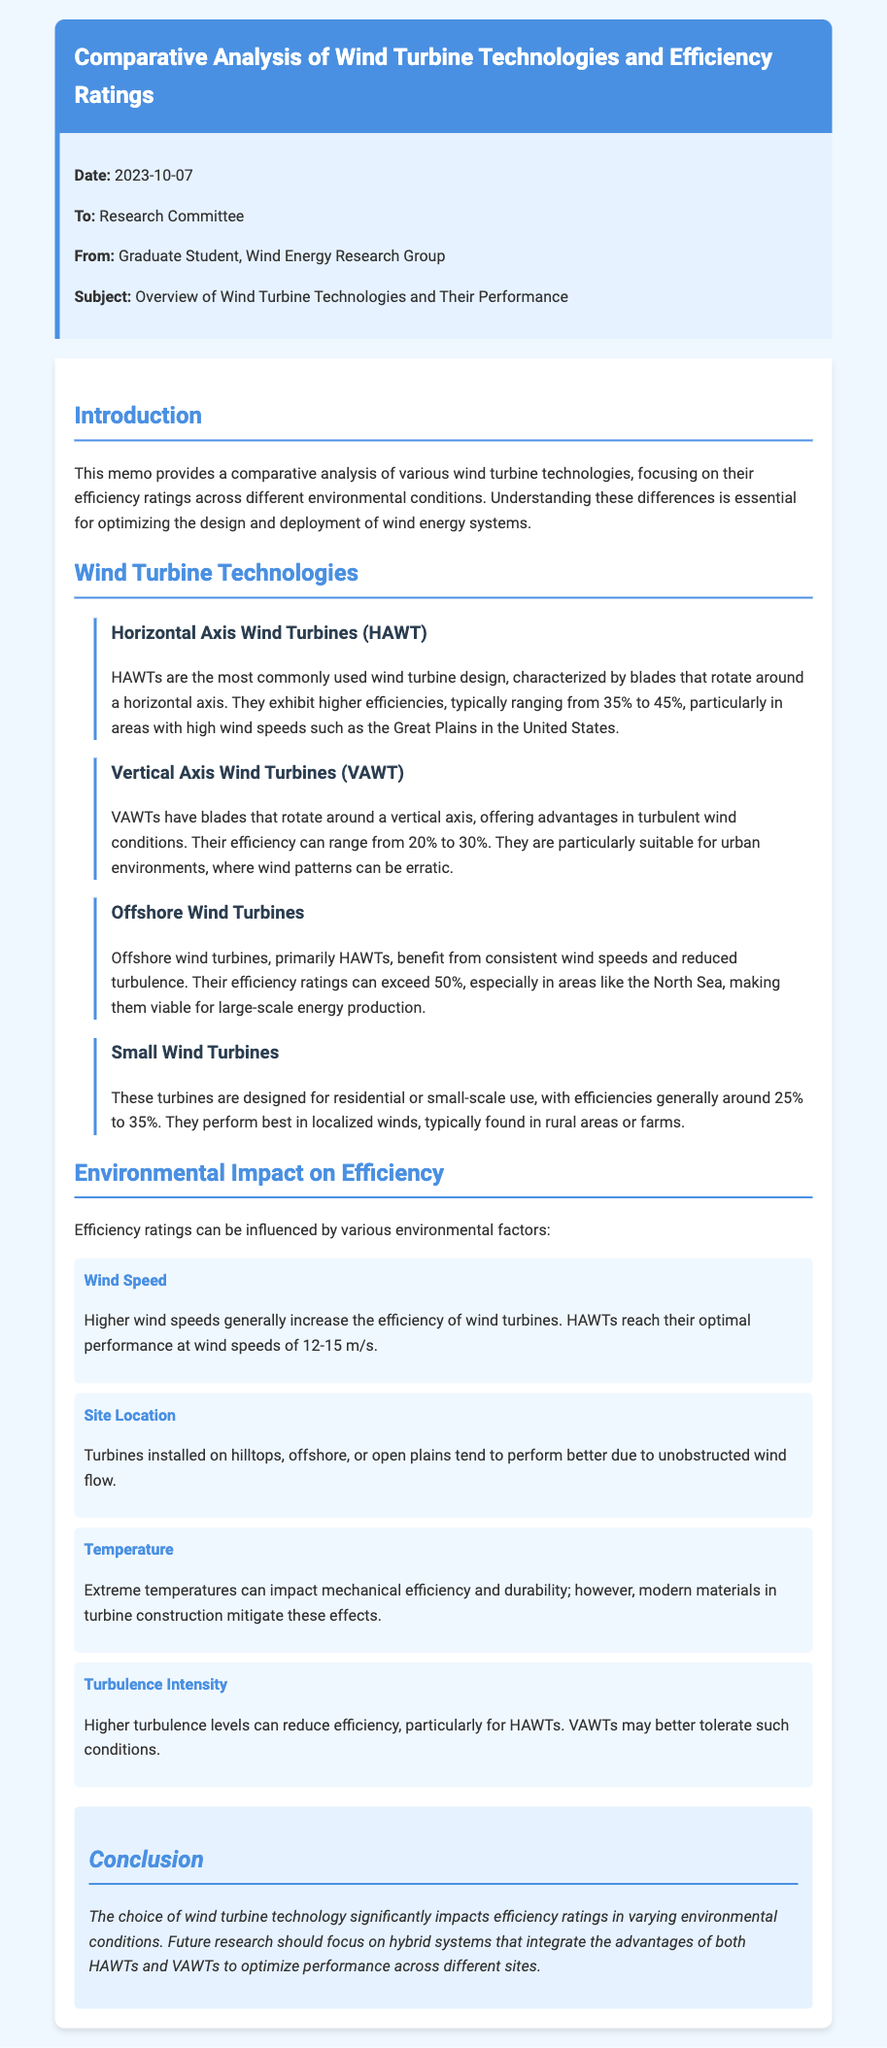What type of document is this? The document is a memo addressing the research committee, providing a comparative analysis of wind turbine technologies.
Answer: memo Who is the memo addressed to? The memo specifies that it is directed to the Research Committee.
Answer: Research Committee What is the highest efficiency rating mentioned for offshore wind turbines? The memo states that offshore wind turbines can exceed an efficiency rating of 50%.
Answer: 50% Which wind turbine type is characterized by blades rotating around a horizontal axis? The document identifies Horizontal Axis Wind Turbines (HAWT) as having blades that rotate around a horizontal axis.
Answer: Horizontal Axis Wind Turbines (HAWT) What environmental factor generally increases the efficiency of wind turbines? The memo mentions that higher wind speeds can increase the efficiency of wind turbines.
Answer: Wind Speed What is the efficiency range for Vertical Axis Wind Turbines (VAWT)? The document indicates that VAWTs have an efficiency range of 20% to 30%.
Answer: 20% to 30% What is the conclusion regarding future research in wind turbine technology? The conclusion suggests that future research should focus on hybrid systems integrating HAWTs and VAWTs.
Answer: hybrid systems What environmental factor is mentioned as potentially impacting mechanical efficiency and durability? The memo discusses that extreme temperatures can impact mechanical efficiency and durability.
Answer: Temperature What is one advantage of Vertical Axis Wind Turbines (VAWT) mentioned in the memo? The document states that VAWTs offer advantages in turbulent wind conditions.
Answer: turbulent wind conditions 